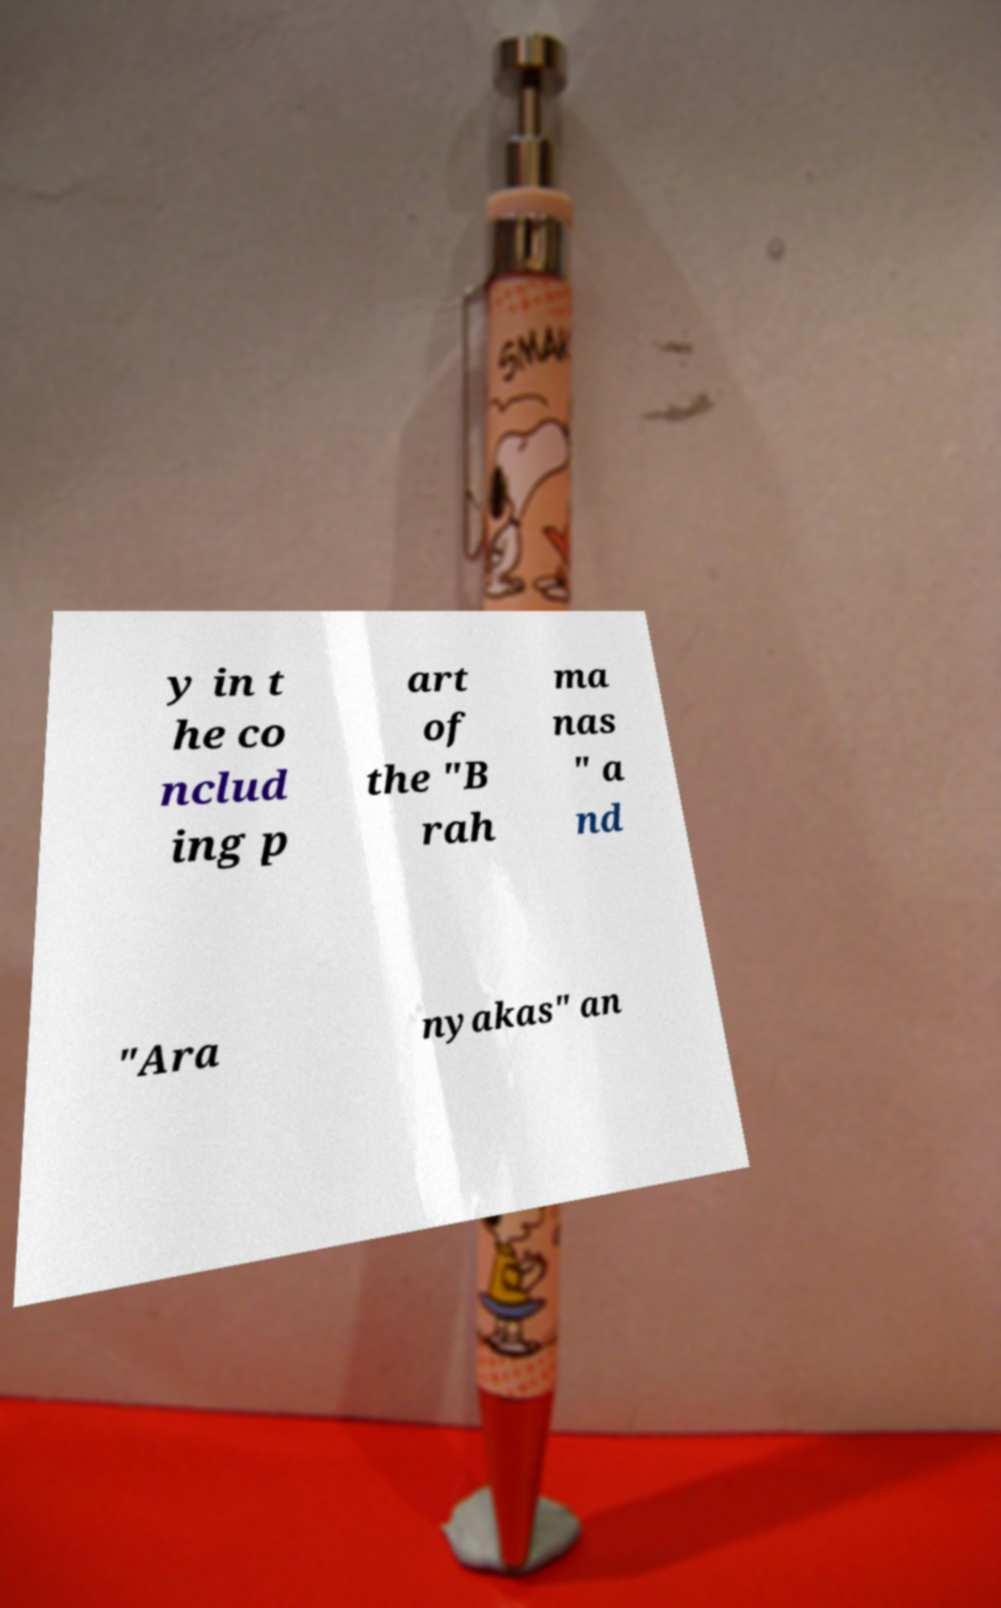Please identify and transcribe the text found in this image. y in t he co nclud ing p art of the "B rah ma nas " a nd "Ara nyakas" an 